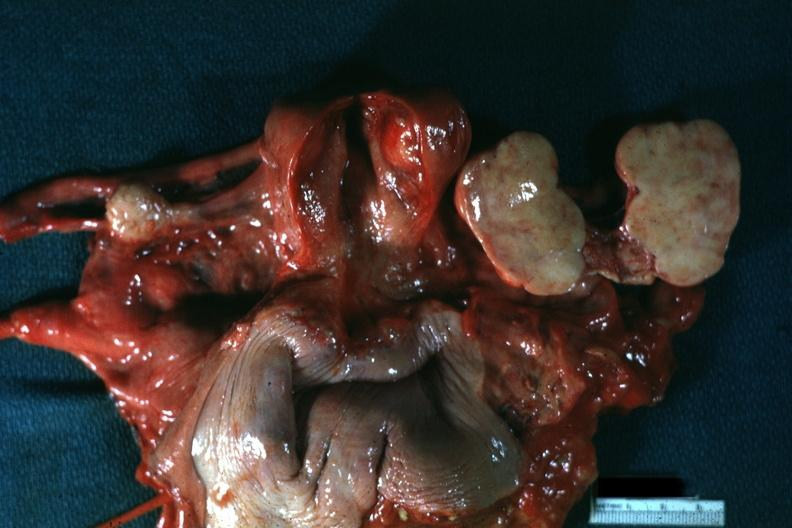what opened like a book typical for this lesion?
Answer the question using a single word or phrase. All pelvic organs tumor mass 